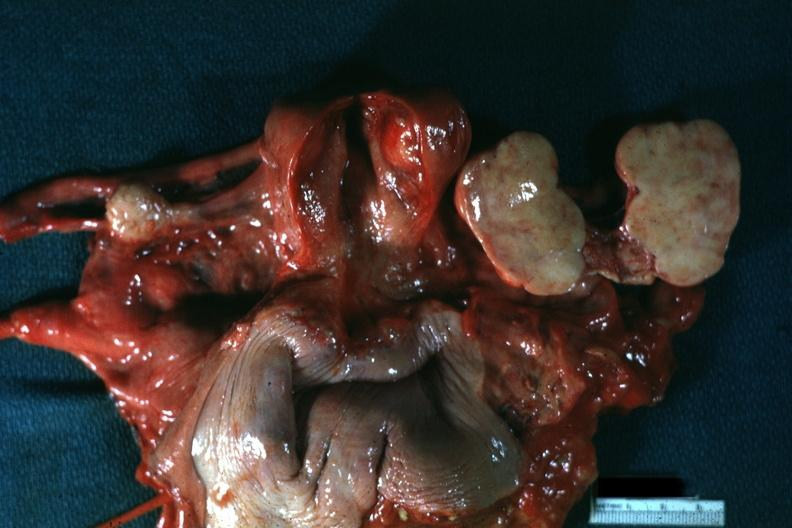what opened like a book typical for this lesion?
Answer the question using a single word or phrase. All pelvic organs tumor mass 